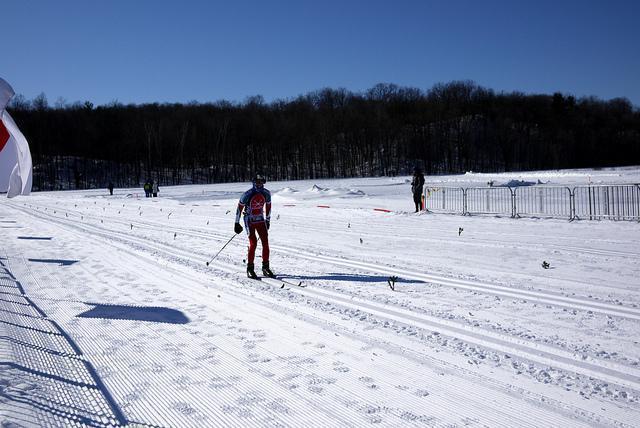How many people are there?
Give a very brief answer. 5. How many skiers are in the photo?
Give a very brief answer. 1. 